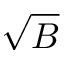<formula> <loc_0><loc_0><loc_500><loc_500>\sqrt { B }</formula> 